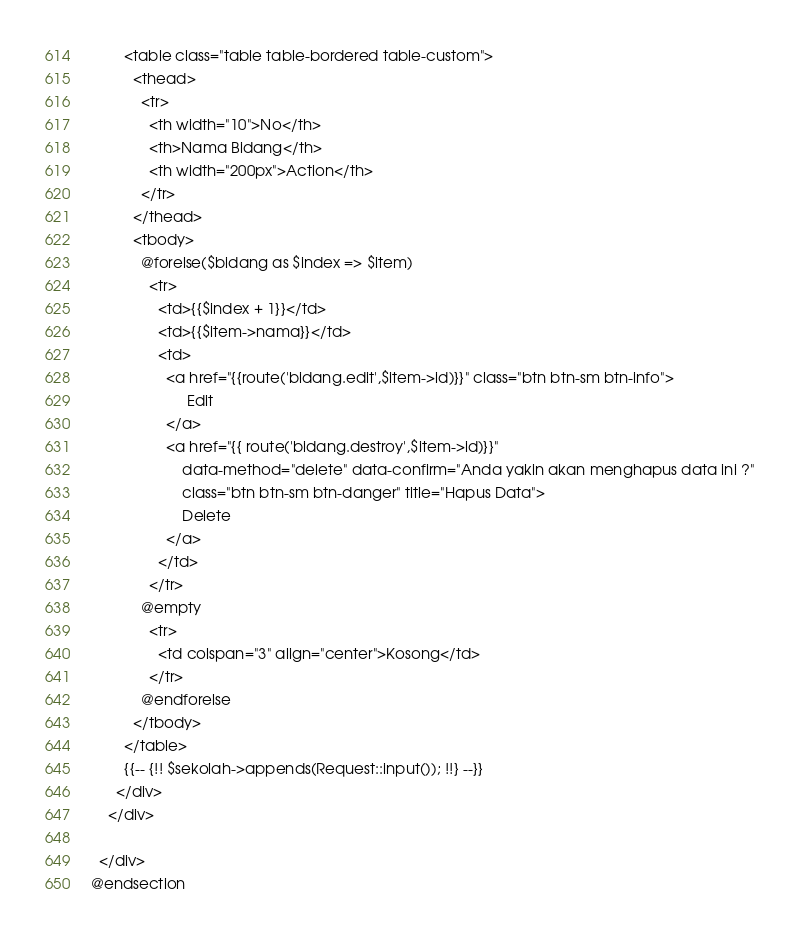<code> <loc_0><loc_0><loc_500><loc_500><_PHP_>        <table class="table table-bordered table-custom">
          <thead>
            <tr>
              <th width="10">No</th>
              <th>Nama Bidang</th>
              <th width="200px">Action</th>
            </tr>
          </thead>
          <tbody>
            @forelse($bidang as $index => $item)
              <tr>
                <td>{{$index + 1}}</td>
                <td>{{$item->nama}}</td>
                <td>
                  <a href="{{route('bidang.edit',$item->id)}}" class="btn btn-sm btn-info">
                       Edit
                  </a>
                  <a href="{{ route('bidang.destroy',$item->id)}}"
                      data-method="delete" data-confirm="Anda yakin akan menghapus data ini ?"
                      class="btn btn-sm btn-danger" title="Hapus Data">
                      Delete
                  </a>
                </td>
              </tr> 
            @empty
              <tr>
                <td colspan="3" align="center">Kosong</td>
              </tr>
            @endforelse
          </tbody>
        </table>
        {{-- {!! $sekolah->appends(Request::input()); !!} --}}
      </div>
    </div>

  </div>
@endsection
</code> 